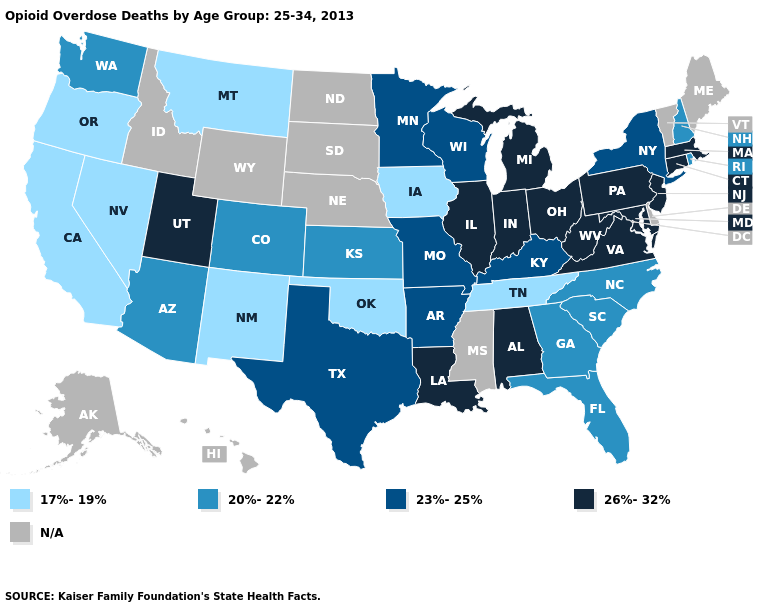Which states have the highest value in the USA?
Quick response, please. Alabama, Connecticut, Illinois, Indiana, Louisiana, Maryland, Massachusetts, Michigan, New Jersey, Ohio, Pennsylvania, Utah, Virginia, West Virginia. Among the states that border West Virginia , does Maryland have the highest value?
Concise answer only. Yes. What is the value of New York?
Quick response, please. 23%-25%. What is the lowest value in the West?
Keep it brief. 17%-19%. Among the states that border Wisconsin , which have the highest value?
Give a very brief answer. Illinois, Michigan. Is the legend a continuous bar?
Write a very short answer. No. Which states hav the highest value in the South?
Give a very brief answer. Alabama, Louisiana, Maryland, Virginia, West Virginia. Which states have the lowest value in the USA?
Concise answer only. California, Iowa, Montana, Nevada, New Mexico, Oklahoma, Oregon, Tennessee. What is the value of Iowa?
Short answer required. 17%-19%. Which states hav the highest value in the South?
Quick response, please. Alabama, Louisiana, Maryland, Virginia, West Virginia. Does the first symbol in the legend represent the smallest category?
Give a very brief answer. Yes. Does the map have missing data?
Write a very short answer. Yes. Name the states that have a value in the range 26%-32%?
Be succinct. Alabama, Connecticut, Illinois, Indiana, Louisiana, Maryland, Massachusetts, Michigan, New Jersey, Ohio, Pennsylvania, Utah, Virginia, West Virginia. What is the lowest value in states that border Massachusetts?
Be succinct. 20%-22%. 